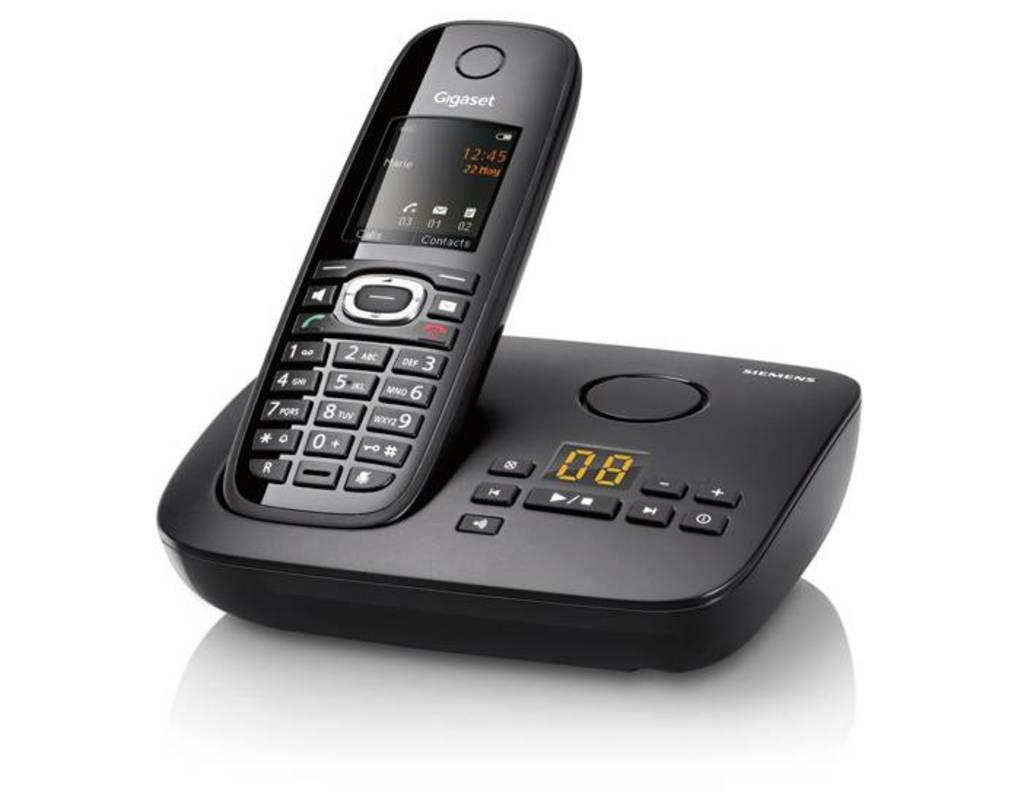<image>
Offer a succinct explanation of the picture presented. A old fashioned phone on a stand with the number 08 visible. 